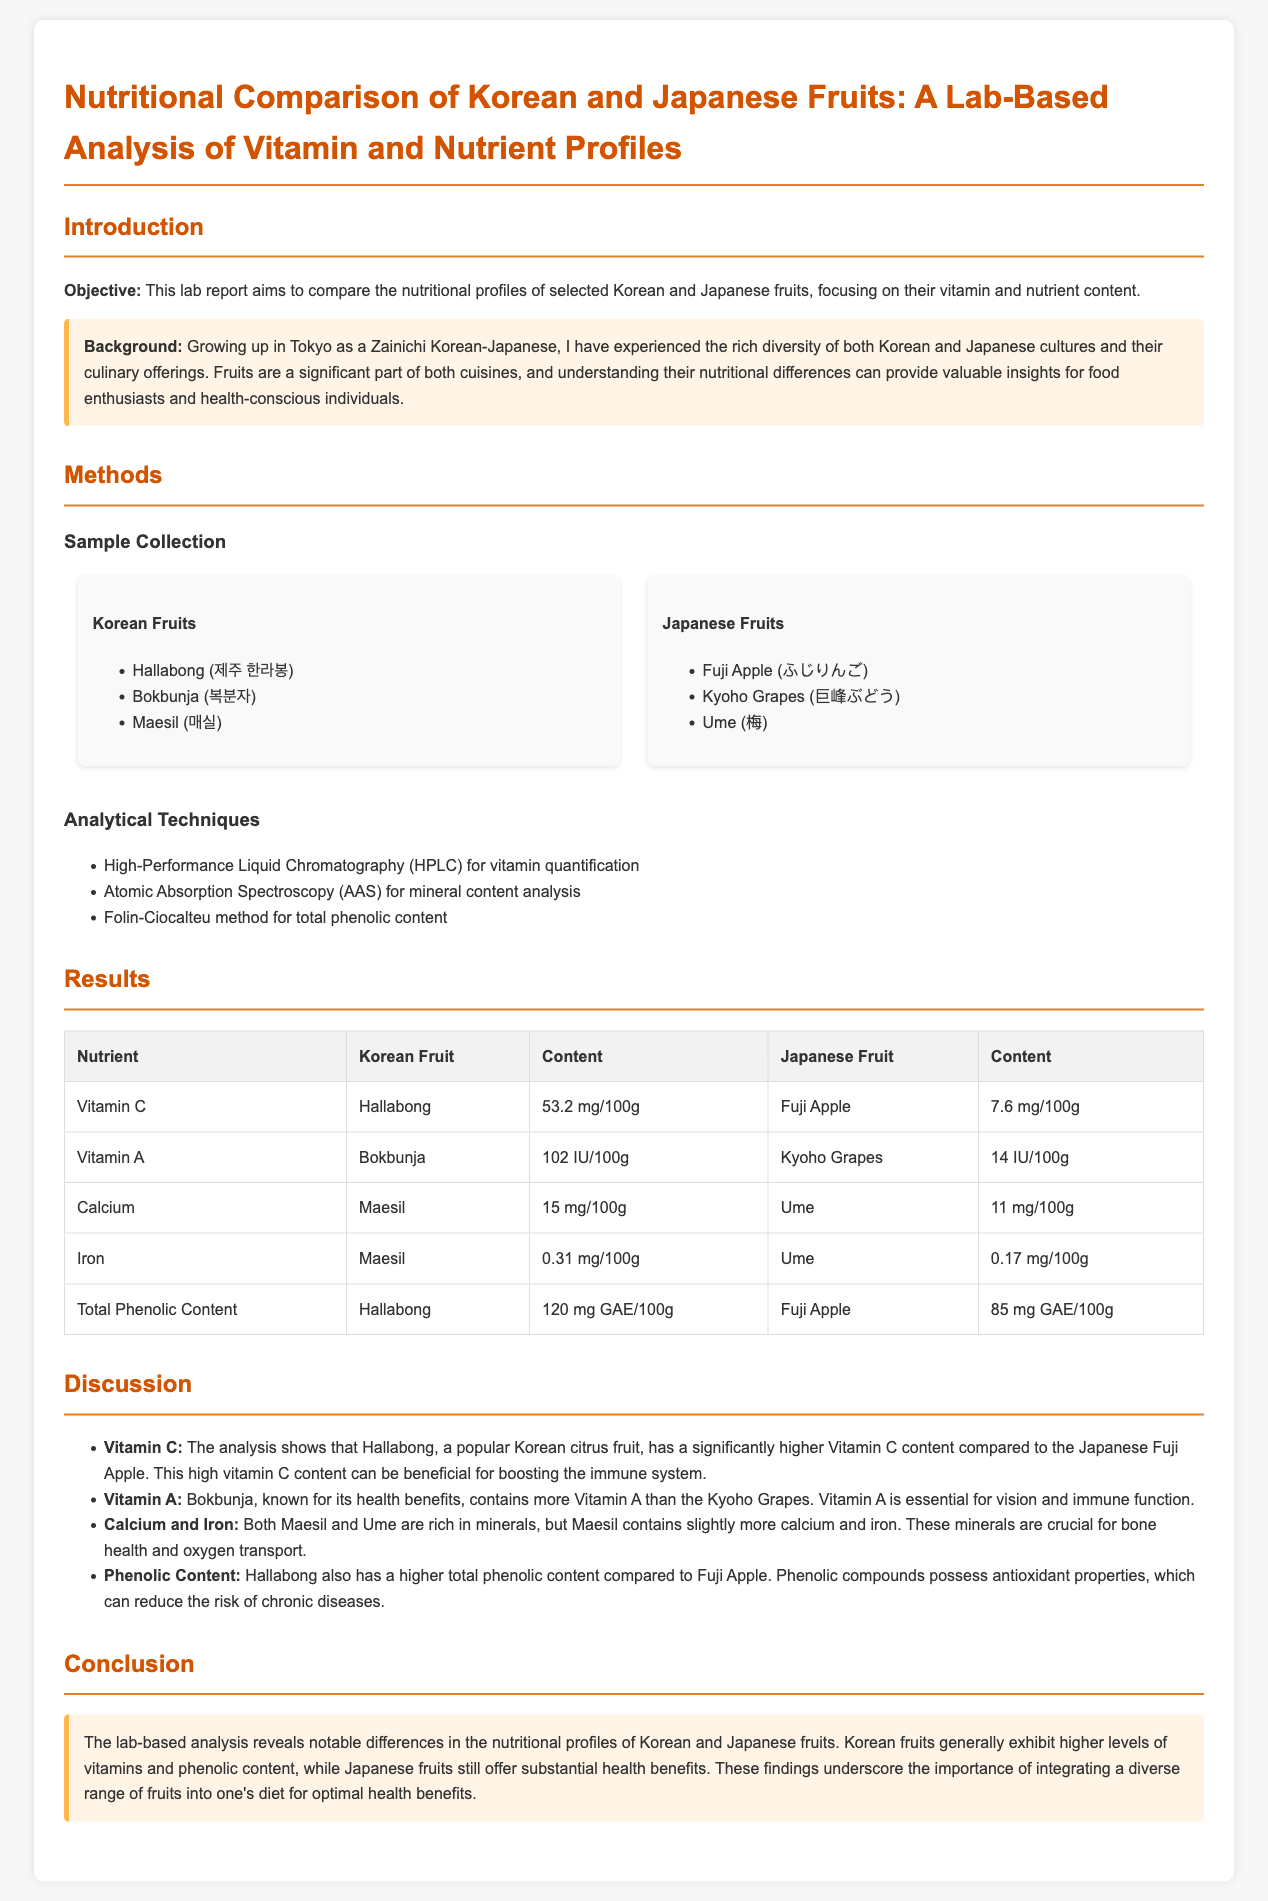what is the objective of the lab report? The objective is to compare the nutritional profiles of selected Korean and Japanese fruits, focusing on their vitamin and nutrient content.
Answer: compare the nutritional profiles which Korean fruit has the highest Vitamin C content? The table shows that Hallabong has the highest Vitamin C content at 53.2 mg/100g.
Answer: Hallabong how much Vitamin A is found in Bokbunja? The result indicates that Bokbunja contains 102 IU/100g of Vitamin A.
Answer: 102 IU/100g what analytical technique is used for mineral content analysis? The report states that Atomic Absorption Spectroscopy (AAS) is used for mineral content analysis.
Answer: Atomic Absorption Spectroscopy which fruit has higher total phenolic content, Hallabong or Fuji Apple? The results show that Hallabong has a total phenolic content of 120 mg GAE/100g, which is higher than Fuji Apple's 85 mg GAE/100g.
Answer: Hallabong which nutrient is Maesil higher in compared to Ume? The document indicates that Maesil contains slightly more calcium and iron than Ume.
Answer: calcium and iron what health benefit does Vitamin C provide? The discussion highlights that Vitamin C can be beneficial for boosting the immune system.
Answer: boosting the immune system what is emphasized as important for optimal health benefits? The conclusion underscores the importance of integrating a diverse range of fruits into one's diet.
Answer: diverse range of fruits 